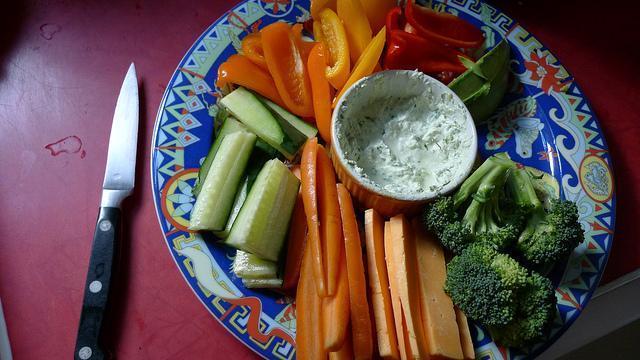How many carrots are in the photo?
Give a very brief answer. 2. 